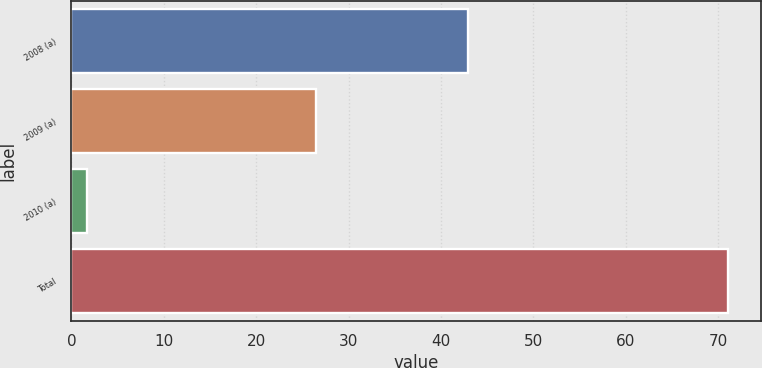Convert chart. <chart><loc_0><loc_0><loc_500><loc_500><bar_chart><fcel>2008 (a)<fcel>2009 (a)<fcel>2010 (a)<fcel>Total<nl><fcel>42.9<fcel>26.5<fcel>1.7<fcel>71.1<nl></chart> 